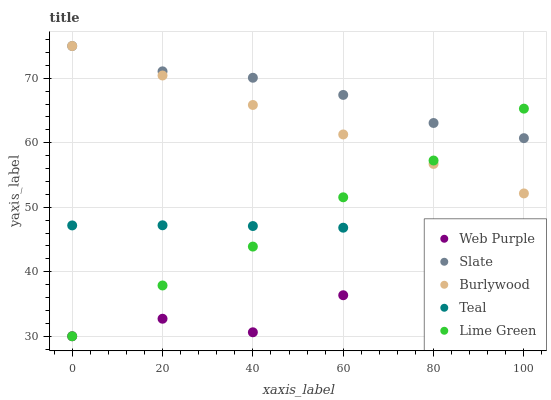Does Web Purple have the minimum area under the curve?
Answer yes or no. Yes. Does Slate have the maximum area under the curve?
Answer yes or no. Yes. Does Lime Green have the minimum area under the curve?
Answer yes or no. No. Does Lime Green have the maximum area under the curve?
Answer yes or no. No. Is Burlywood the smoothest?
Answer yes or no. Yes. Is Web Purple the roughest?
Answer yes or no. Yes. Is Lime Green the smoothest?
Answer yes or no. No. Is Lime Green the roughest?
Answer yes or no. No. Does Web Purple have the lowest value?
Answer yes or no. Yes. Does Slate have the lowest value?
Answer yes or no. No. Does Slate have the highest value?
Answer yes or no. Yes. Does Lime Green have the highest value?
Answer yes or no. No. Is Teal less than Burlywood?
Answer yes or no. Yes. Is Slate greater than Teal?
Answer yes or no. Yes. Does Slate intersect Lime Green?
Answer yes or no. Yes. Is Slate less than Lime Green?
Answer yes or no. No. Is Slate greater than Lime Green?
Answer yes or no. No. Does Teal intersect Burlywood?
Answer yes or no. No. 